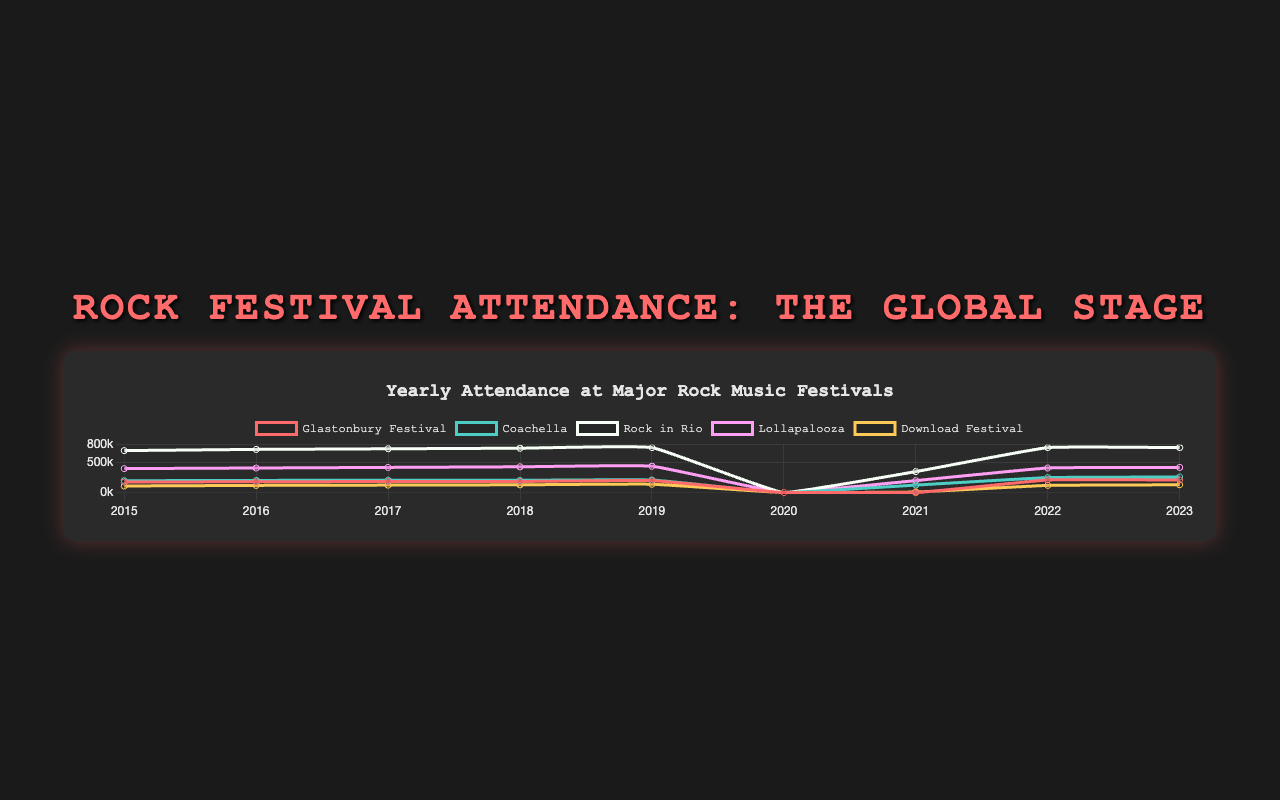Which festival had the highest attendance in 2015? Look at the attendance values for each festival in 2015. Compare them to find the highest one.
Answer: Rock in Rio How many people attended Glastonbury Festival in total from 2015 to 2019? Sum up the yearly attendance of Glastonbury Festival from 2015 to 2019: 177000 + 180000 + 185000 + 185000 + 200000.
Answer: 927000 Which festival showed an increase in attendance every consecutive year from 2015 to 2019? Analyze the attendance data for each festival from 2015 to 2019 and check for consistent year-on-year increases.
Answer: Coachella Valley Music and Arts Festival In which year did all festivals record zero attendance, and why might this be the case? Look for the year where all festivals have an attendance of 0 and consider global events that might affect large gatherings.
Answer: 2020, likely due to the COVID-19 pandemic Compare the attendance of Download Festival in 2021 and 2022. By what percentage did it increase? Subtract the 2021 attendance from the 2022 attendance, and then divide the result by the 2021 attendance. Multiply by 100 to get the percentage increase: (120000 - 10000) / 10000 * 100.
Answer: 1100% Which festival experienced the most significant drop in attendance from 2019 to 2020? Compare the drop in attendance for each festival from 2019 to 2020 by calculating the difference for each.
Answer: All festivals experienced a drop of 100%, so they all equally experienced the most significant drop What was the average attendance for Lollapalooza from 2015 to 2019? Sum the yearly attendance of Lollapalooza from 2015 to 2019 and then divide by the number of years: (400000 + 410000 + 420000 + 430000 + 440000) / 5.
Answer: 420000 Was there a year where Coachella had higher attendance than any other festival? Compare Coachella's attendance year by year with other festivals to see if it was ever the highest.
Answer: No By how much did the attendance of Rock in Rio change between 2021 and 2022? Subtract the 2021 attendance from the 2022 attendance for Rock in Rio: 750000 - 350000.
Answer: 400000 Which festival had the highest attendance in 2023, and what was the attendance? Look at the 2023 attendance values for each festival and identify the highest one.
Answer: Rock in Rio, 750000 